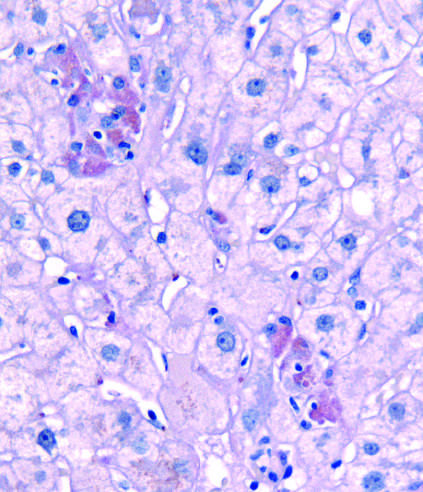what indicate foci of hepatocytes undergoing necrosis in this pas-d-stained biopsy from a patient with acute hepatitis b?
Answer the question using a single word or phrase. Clusters of pigmented hepatocytes with eosinophilic cytoplasm 